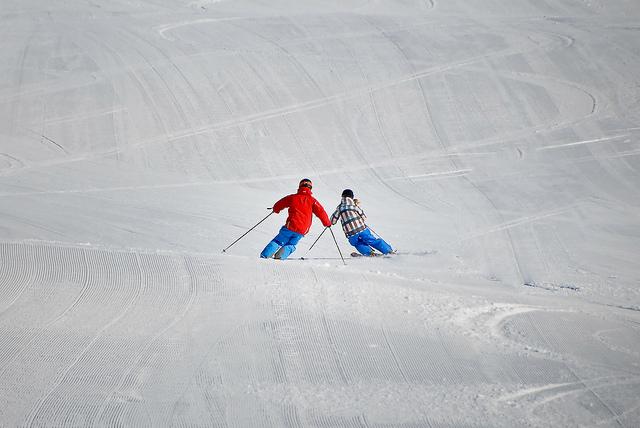What color is the left person's coat?
Quick response, please. Red. Are these people going in the same direction?
Quick response, please. Yes. Is there snow on the ground?
Be succinct. Yes. 